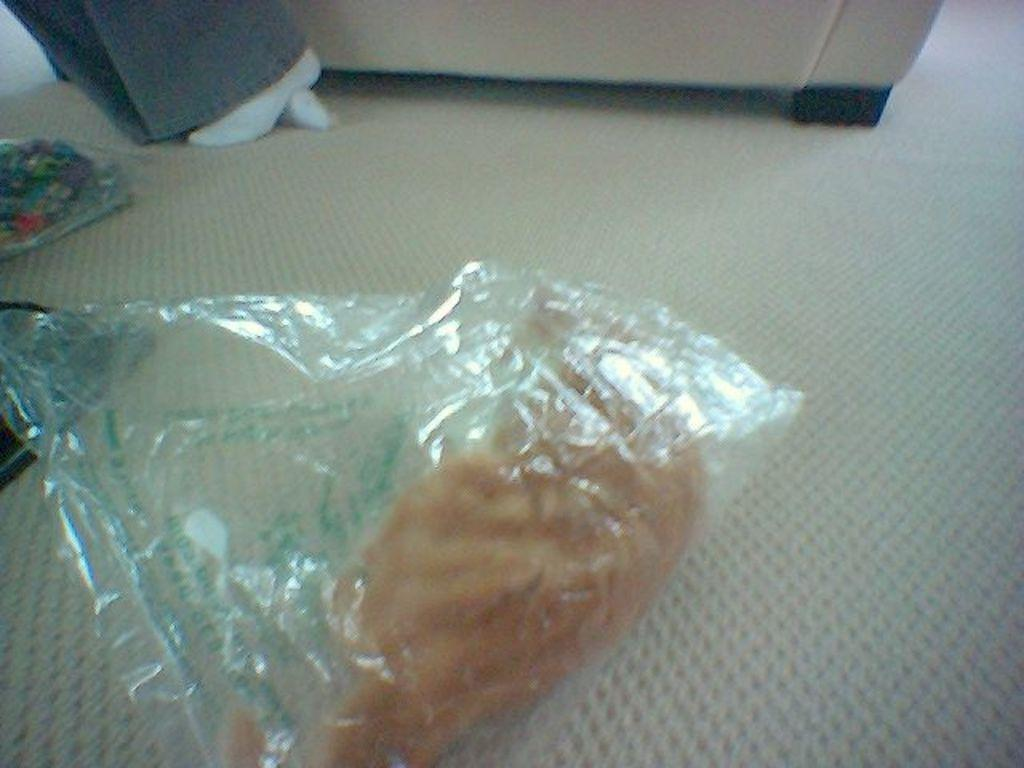What is the food item in the image covered with? There is a food item in a cover in the image. What can be seen on the mat in the image? There are objects on a mat in the image. What type of furniture is present in the image? There is a chair in the image. Whose legs are visible in the image? The legs of a person are visible in the image. Reasoning: Let' Let's think step by step in order to produce the conversation. We start by identifying the main subject in the image, which is the food item in a cover. Then, we expand the conversation to include other items and objects that are also visible, such as the objects on the mat, the chair, and the person's legs. Each question is designed to elicit a specific detail about the image that is known from the provided facts. Absurd Question/Answer: How many sisters are playing the guitar in the image? There are no sisters or guitar present in the image. What color is the person's toe in the image? There is no toe visible in the image; only the person's legs are visible. How many sisters are playing the guitar in the image? There are no sisters or guitar present in the image. What color is the person's toe in the image? There is no toe visible in the image; only the person's legs are visible. 